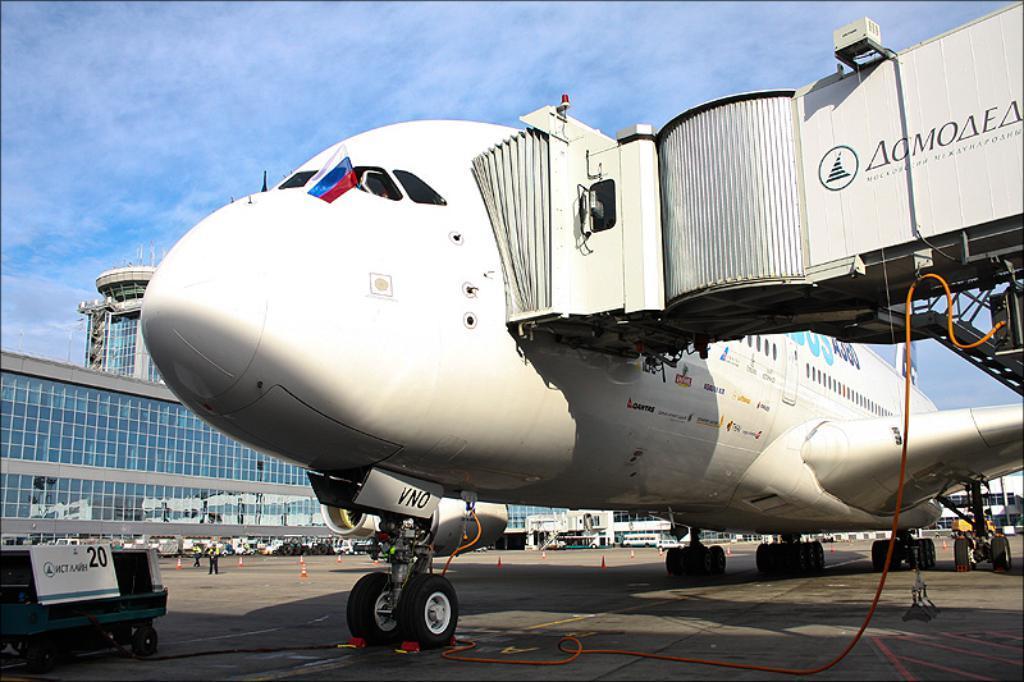In one or two sentences, can you explain what this image depicts? In this picture I can see a plane on the ground, behind we can see buildings, vehicles and we can see a person standing. 